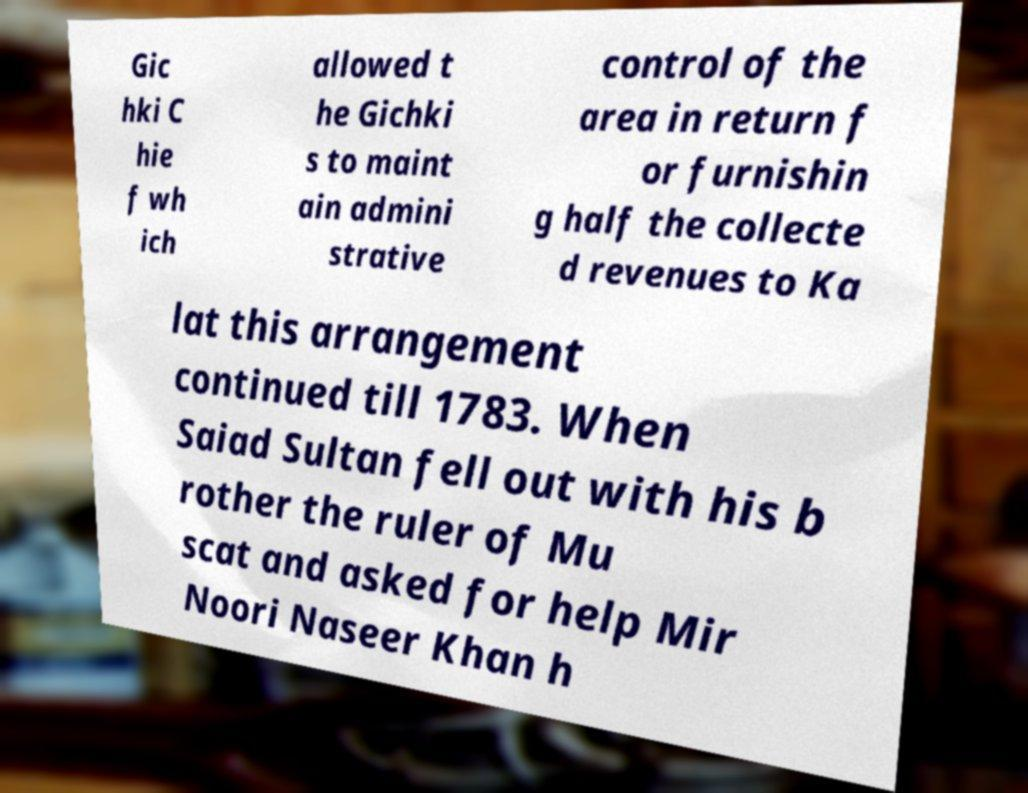I need the written content from this picture converted into text. Can you do that? Gic hki C hie f wh ich allowed t he Gichki s to maint ain admini strative control of the area in return f or furnishin g half the collecte d revenues to Ka lat this arrangement continued till 1783. When Saiad Sultan fell out with his b rother the ruler of Mu scat and asked for help Mir Noori Naseer Khan h 